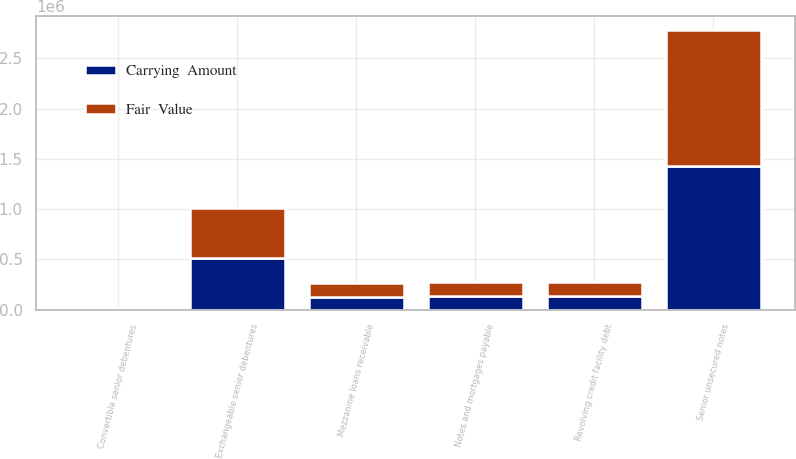<chart> <loc_0><loc_0><loc_500><loc_500><stacked_bar_chart><ecel><fcel>Mezzanine loans receivable<fcel>Notes and mortgages payable<fcel>Senior unsecured notes<fcel>Exchangeable senior debentures<fcel>Convertible senior debentures<fcel>Revolving credit facility debt<nl><fcel>Fair  Value<fcel>133948<fcel>138000<fcel>1.35766e+06<fcel>497898<fcel>10168<fcel>138000<nl><fcel>Carrying  Amount<fcel>128581<fcel>138000<fcel>1.42641e+06<fcel>509982<fcel>10220<fcel>138000<nl></chart> 